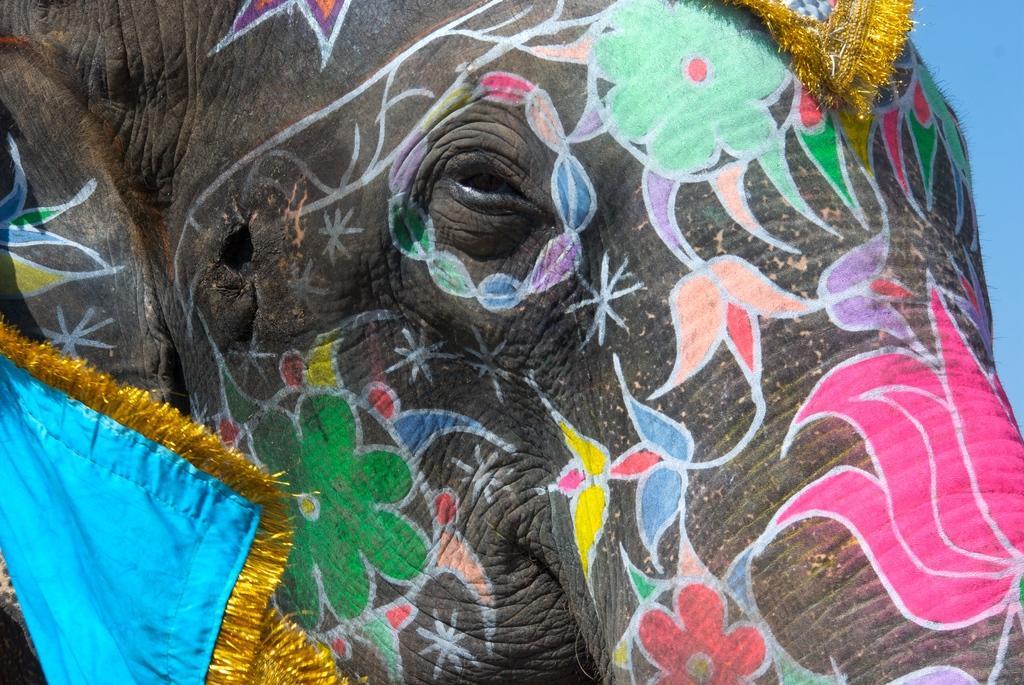Describe this image in one or two sentences. In this image we can see an elephant with painting and clothes. 